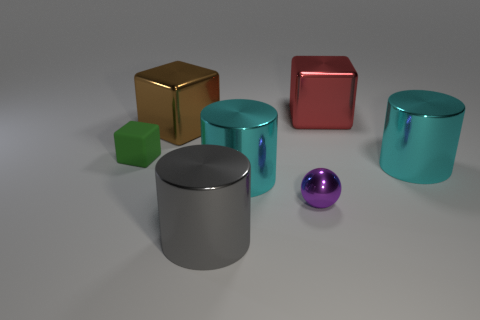What number of big blocks are in front of the big object that is left of the gray shiny thing?
Your answer should be compact. 0. Is the material of the small thing in front of the small green matte cube the same as the tiny green object behind the tiny purple object?
Your response must be concise. No. What number of other metal objects are the same shape as the large red thing?
Ensure brevity in your answer.  1. Is the material of the tiny green thing the same as the big thing behind the large brown shiny block?
Give a very brief answer. No. What is the material of the object that is the same size as the matte cube?
Ensure brevity in your answer.  Metal. Are there any gray shiny objects of the same size as the brown object?
Keep it short and to the point. Yes. There is a red thing that is the same size as the brown metal block; what shape is it?
Make the answer very short. Cube. How many other objects are the same color as the tiny block?
Your answer should be compact. 0. There is a thing that is both behind the small green rubber object and on the left side of the tiny purple ball; what is its shape?
Make the answer very short. Cube. Are there any cyan cylinders that are in front of the large metal cube to the left of the tiny object in front of the matte thing?
Make the answer very short. Yes. 